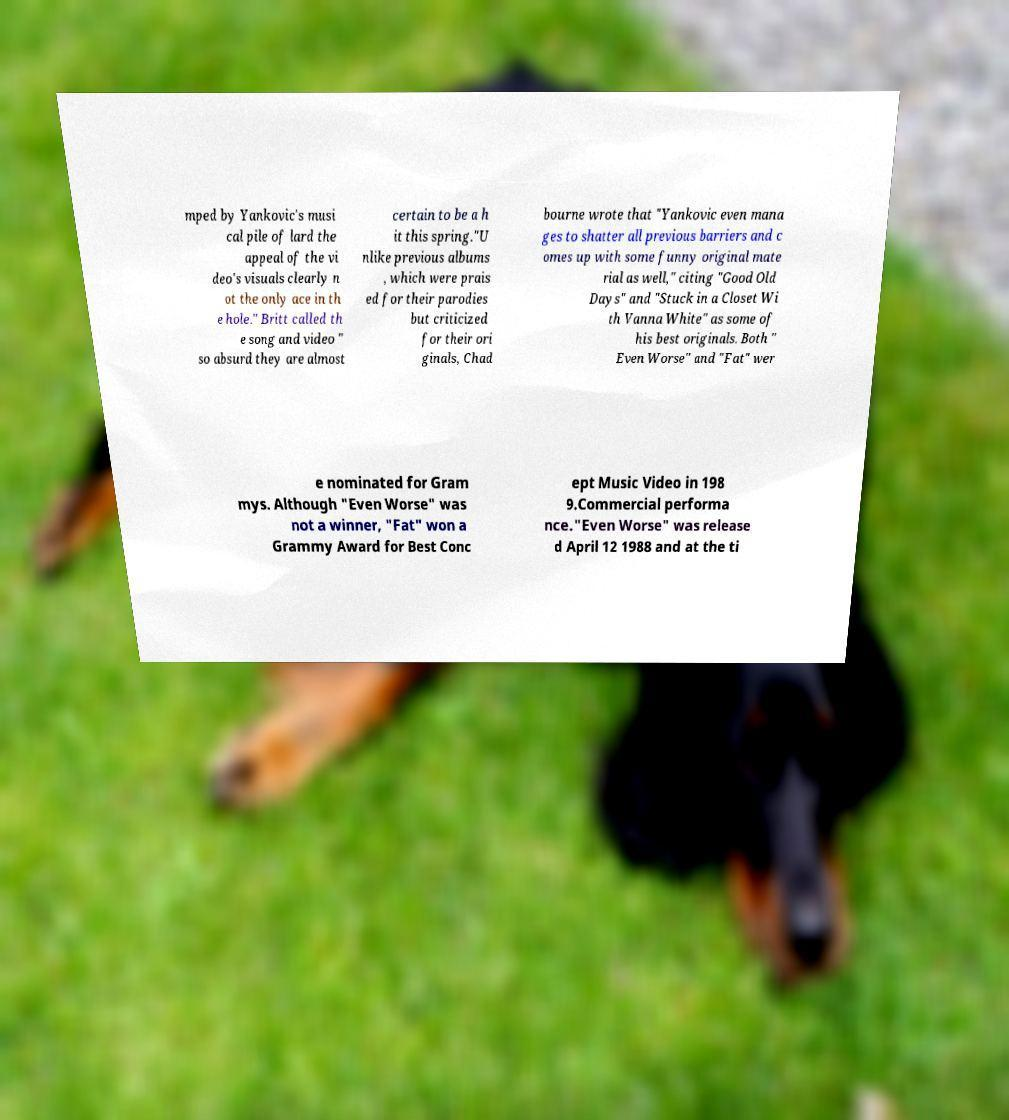Can you read and provide the text displayed in the image?This photo seems to have some interesting text. Can you extract and type it out for me? mped by Yankovic's musi cal pile of lard the appeal of the vi deo's visuals clearly n ot the only ace in th e hole." Britt called th e song and video " so absurd they are almost certain to be a h it this spring."U nlike previous albums , which were prais ed for their parodies but criticized for their ori ginals, Chad bourne wrote that "Yankovic even mana ges to shatter all previous barriers and c omes up with some funny original mate rial as well," citing "Good Old Days" and "Stuck in a Closet Wi th Vanna White" as some of his best originals. Both " Even Worse" and "Fat" wer e nominated for Gram mys. Although "Even Worse" was not a winner, "Fat" won a Grammy Award for Best Conc ept Music Video in 198 9.Commercial performa nce."Even Worse" was release d April 12 1988 and at the ti 